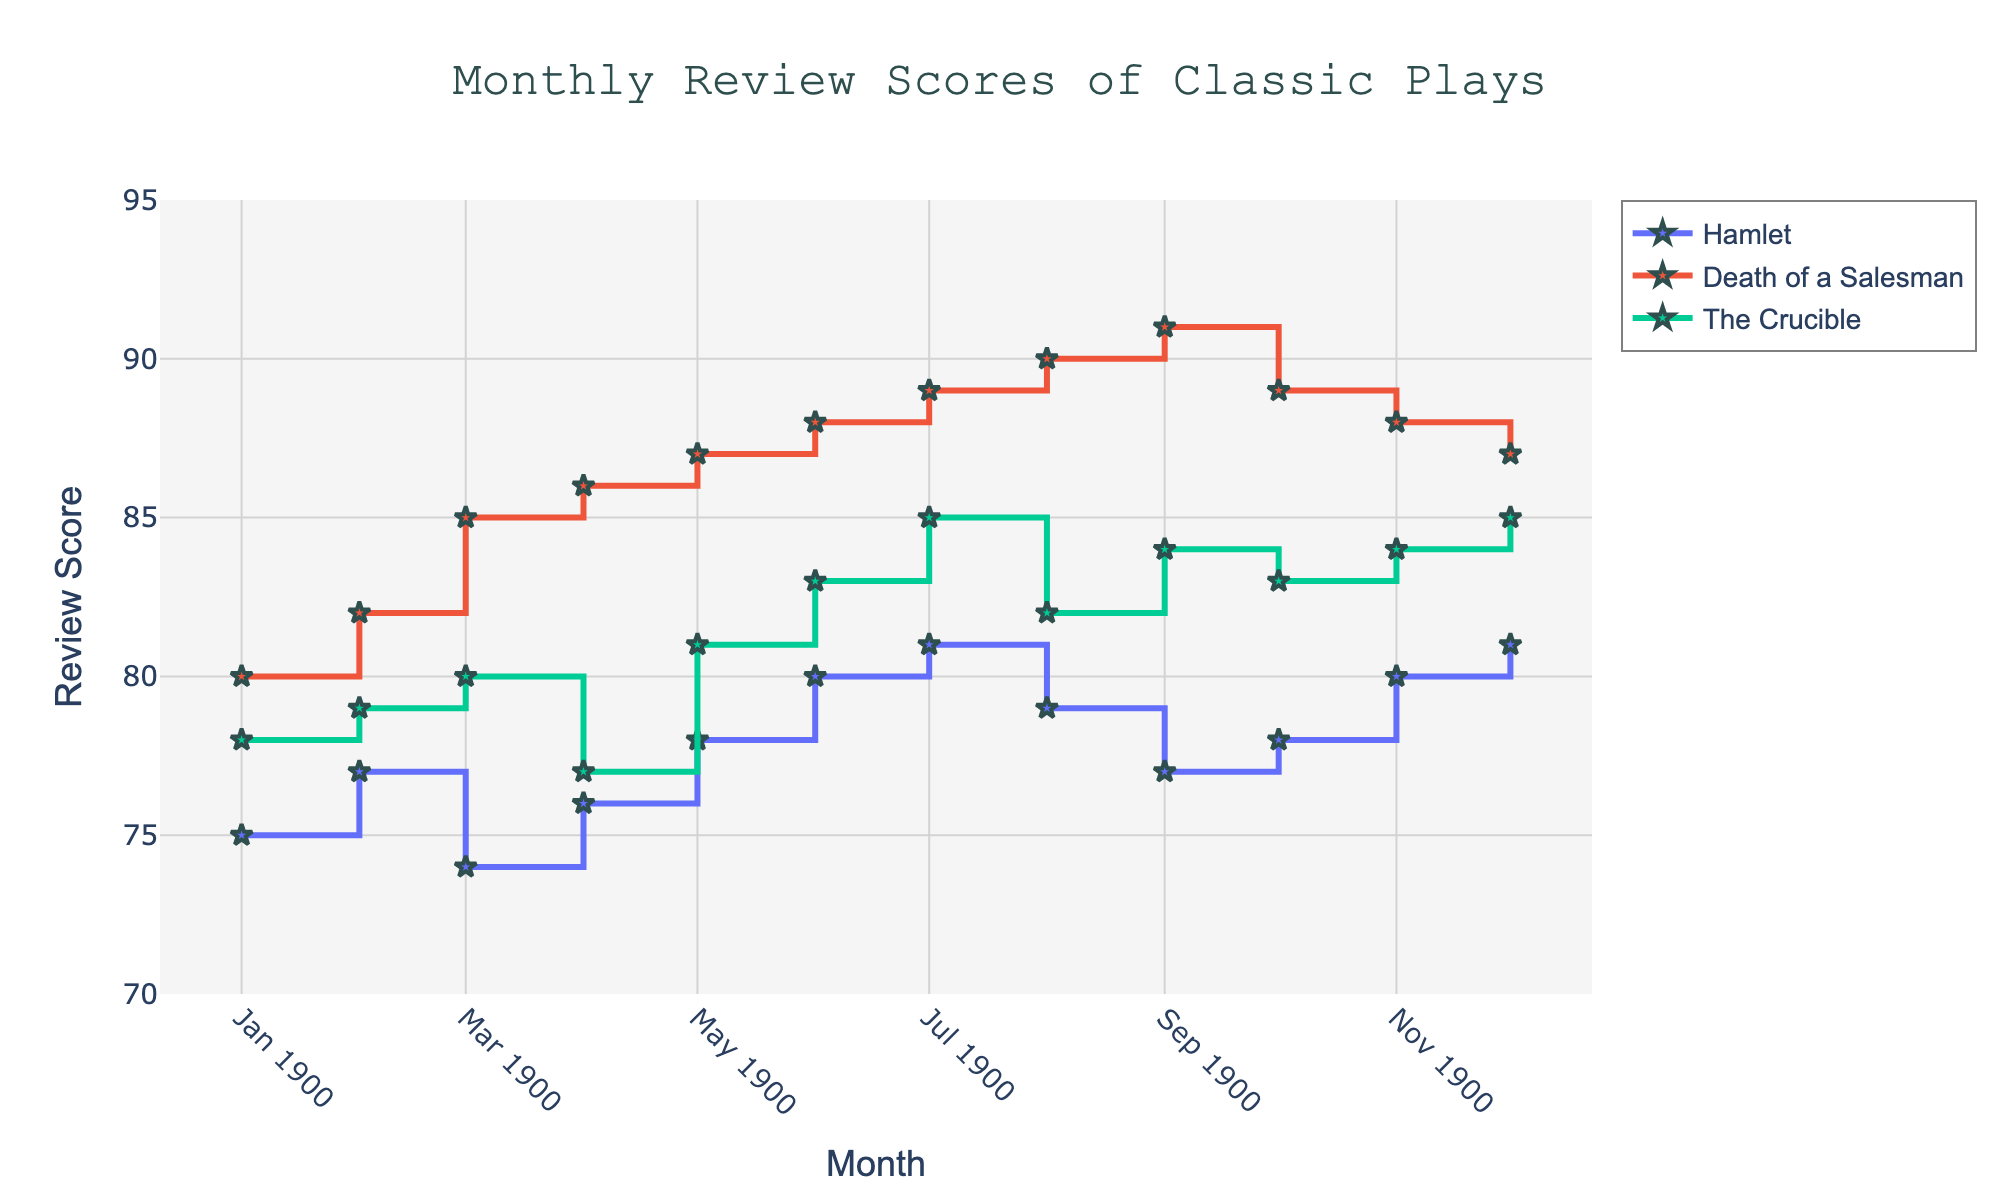What is the title of the plot? The title of the plot can be found at the top center of the figure. It usually gives an overview of what is being visualized. In this case, you can see "Monthly Review Scores of Classic Plays."
Answer: Monthly Review Scores of Classic Plays What is the review score of "Hamlet" in December? To find the review score of "Hamlet" in December, locate the marker for "Hamlet" on the x-axis at December and read the corresponding y-axis value.
Answer: 81 Which play has the highest review score in August? In August, compare the y-axis values for the markers of "Hamlet," "Death of a Salesman," and "The Crucible." The play with the highest y-axis value will have the highest review score. "Death of a Salesman" has the highest review score in August, which is 90.
Answer: Death of a Salesman What is the average review score of "The Crucible" from January to June? Sum the review scores of "The Crucible" from January to June and divide by the number of months. Scores: 78 (Jan) + 79 (Feb) + 80 (Mar) + 77 (Apr) + 81 (May) + 83 (Jun) = 478. There are 6 months, so 478 / 6 = 79.67.
Answer: 79.67 How did the review score of "Death of a Salesman" change from February to March? To understand the change, subtract the February score from the March score for "Death of a Salesman." The scores are 85 (Mar) - 82 (Feb) = 3. Therefore, the review score increased by 3 points.
Answer: Increased by 3 points Which play shows the most improvement from January to December? Calculate the difference between the December and January scores for each play: 
- "Hamlet": 81 - 75 = 6
- "Death of a Salesman": 87 - 80 = 7
- "The Crucible": 85 - 78 = 7
Both "Death of a Salesman" and "The Crucible" improved by 7 points.
Answer: Death of a Salesman and The Crucible During which month does "Hamlet" have its highest review score? On the "Hamlet" trace, find the highest y-axis value and note the corresponding month on the x-axis. The highest score is 81, which occurs in both July and December.
Answer: July and December Is there any month where all plays have the same review score? To find this, you would need to look for a month where the y-axis values for all three plays intersect at the same point. There is no such month where all three plays have exactly the same review score.
Answer: No How does the review score of "The Crucible" in March compare to its score in July? Check the values on the y-axis for "The Crucible" in March and July. In March, the score is 80, and in July, the score is 85. So, the review score increased by 5 points from March to July.
Answer: Increased by 5 points Between which two consecutive months does "Death of a Salesman" see the largest increase in review score? To find this, calculate the difference in review scores for consecutive months for "Death of a Salesman" and identify the largest increase. The largest jump is from February to March (85 - 82 = 3).
Answer: February to March 